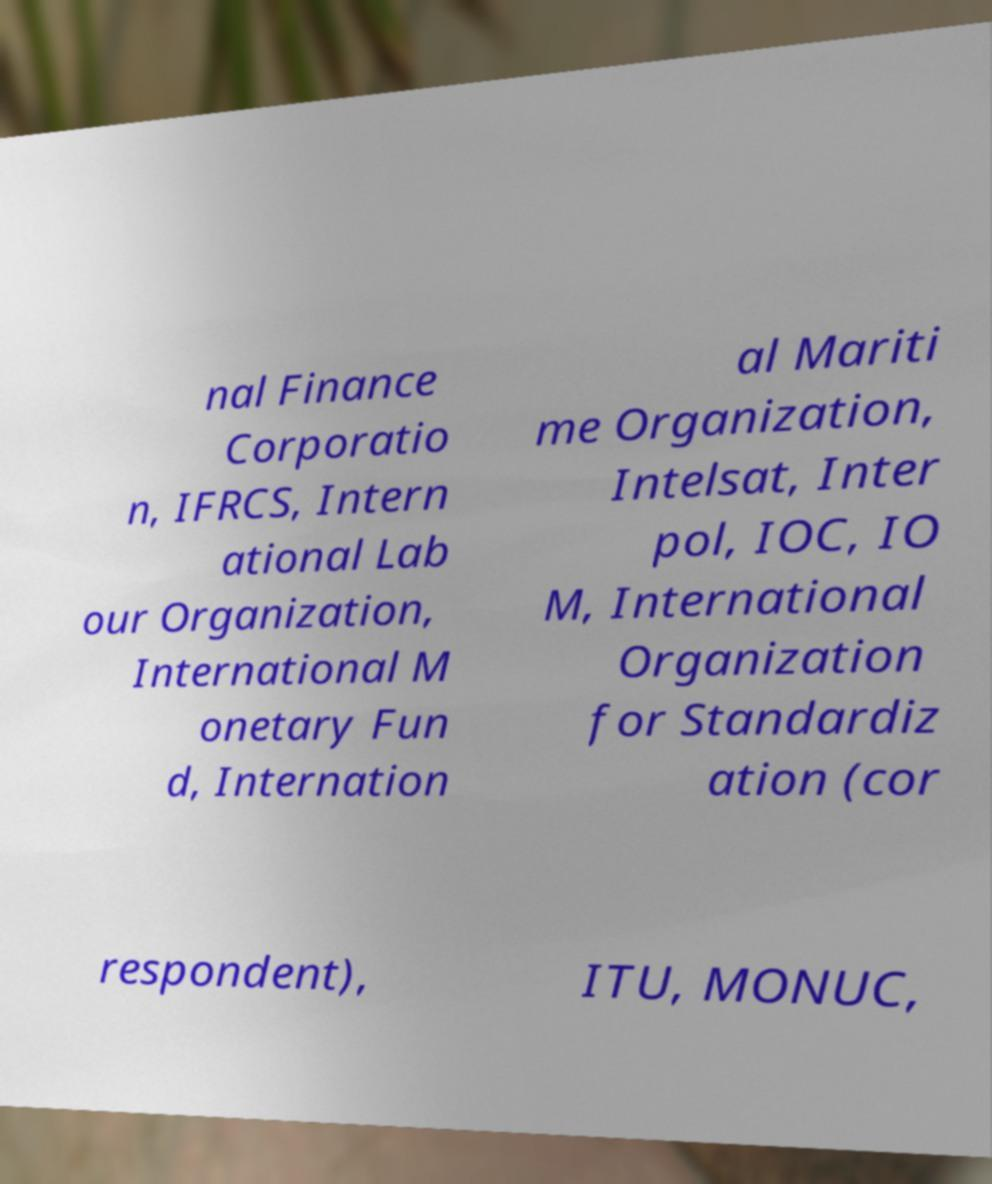What messages or text are displayed in this image? I need them in a readable, typed format. nal Finance Corporatio n, IFRCS, Intern ational Lab our Organization, International M onetary Fun d, Internation al Mariti me Organization, Intelsat, Inter pol, IOC, IO M, International Organization for Standardiz ation (cor respondent), ITU, MONUC, 